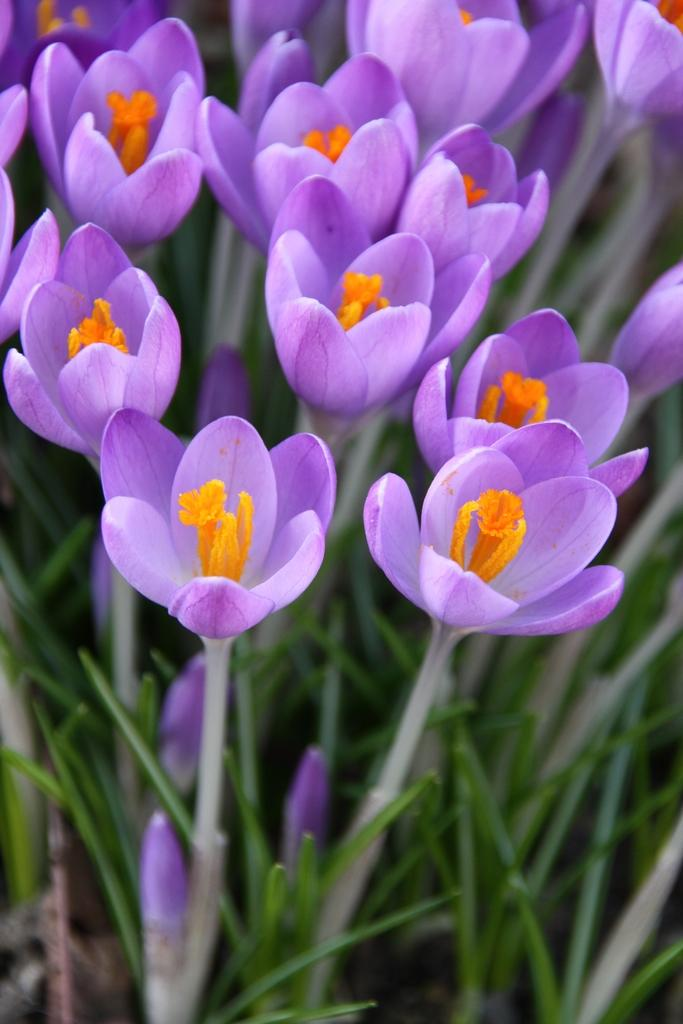What type of living organisms can be seen in the image? There are flowers on plants in the image. Can you describe the plants in the image? The plants in the image have flowers on them. Where is the faucet located in the image? There is no faucet present in the image. What type of party is being held in the image? There is no party depicted in the image; it features flowers on plants. 